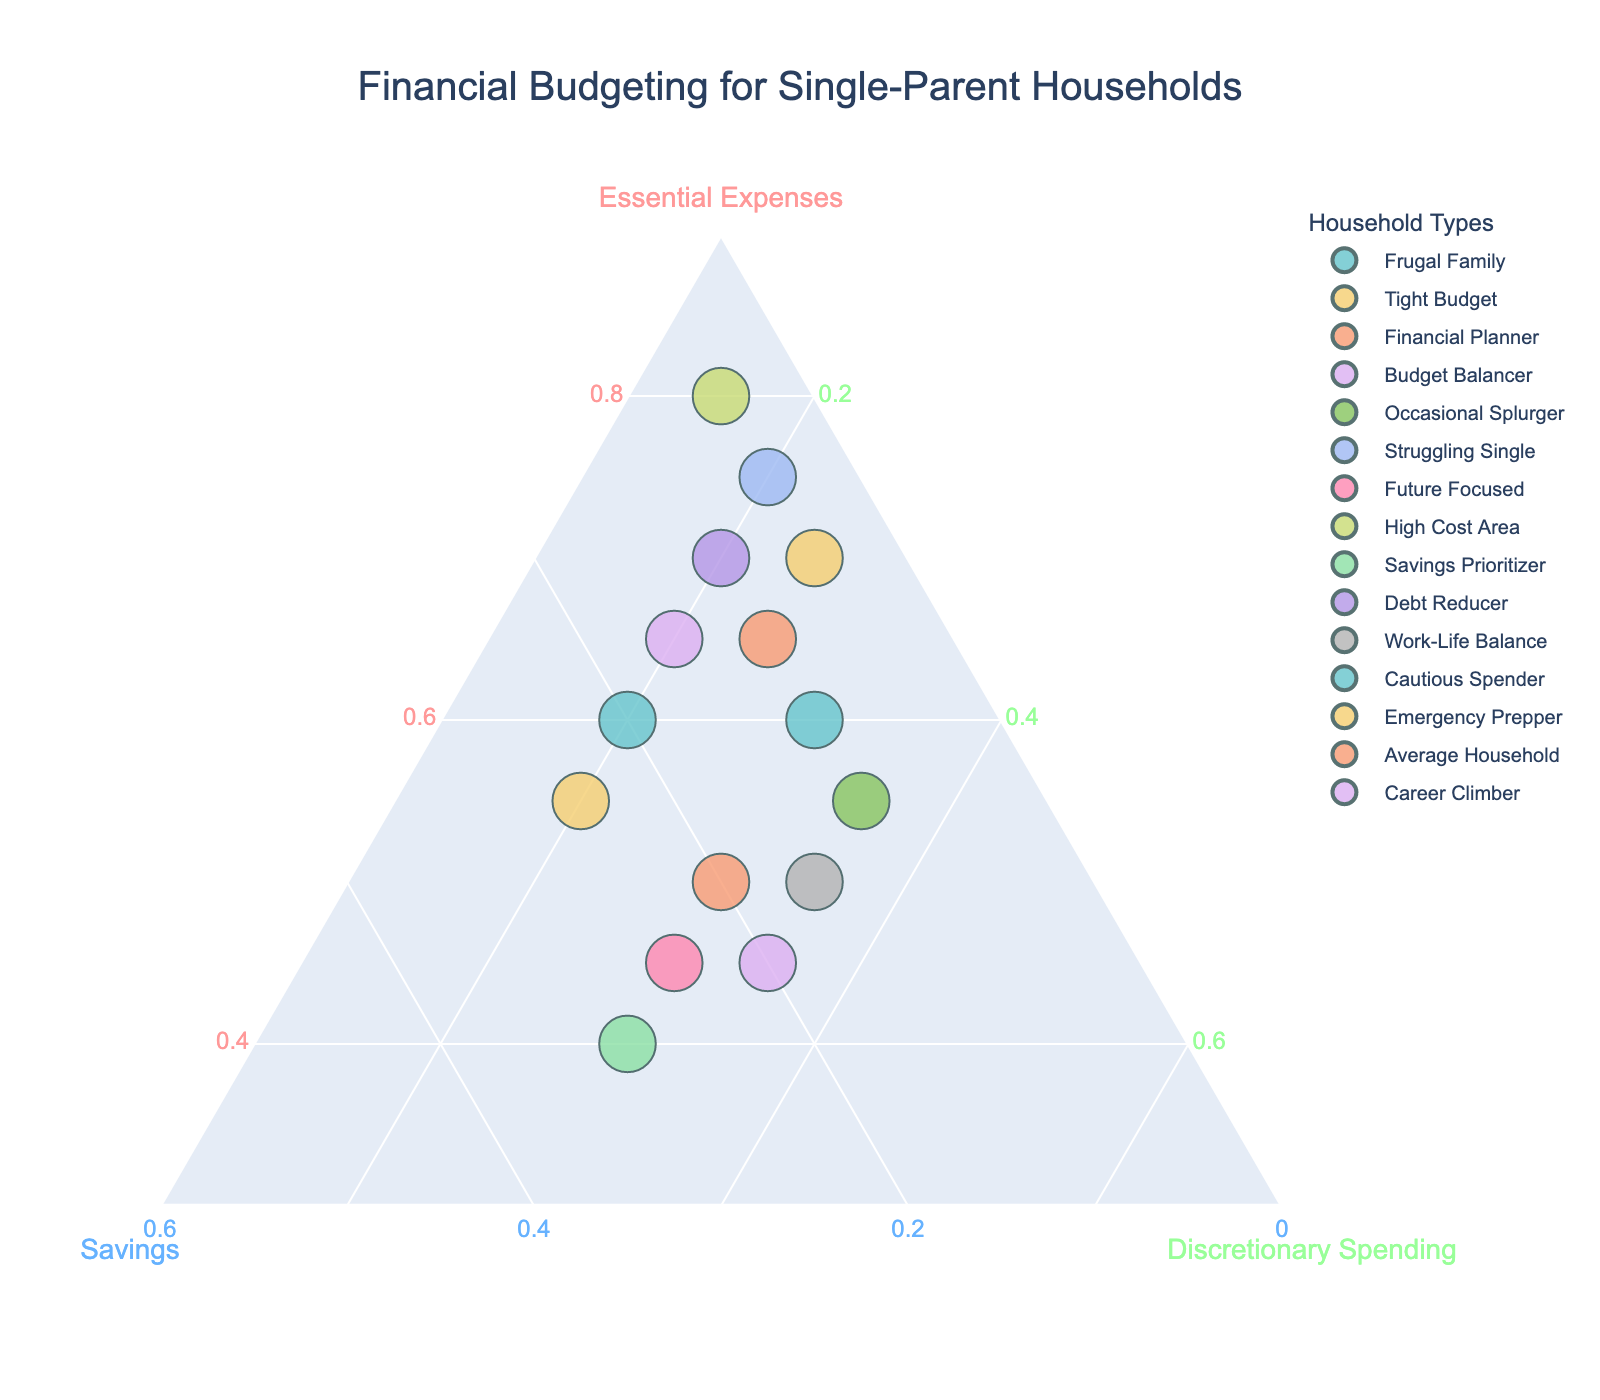What is the title of the plot? The title of the plot is usually located at the top and summarizes the main focus or subject of the chart. In this case, it reads "Financial Budgeting for Single-Parent Households".
Answer: Financial Budgeting for Single-Parent Households Which axis represents "Savings"? The axis labels help identify what each side of the ternary plot represents. The "Savings" label is typically positioned along one of the three axes. In this case, the "Savings" axis is labeled in blue.
Answer: Savings How many households have an essential expense of 70%? This can be identified by looking at the plot and observing which points lie along the 70% mark on the "Essential Expenses" axis. From the plot, "Tight Budget" and "Debt Reducer" have these values.
Answer: 2 Which household has the highest percentage in "Discretionary Spending"? On the plot, households with high discretionary spending will be positioned closer to the "Discretionary Spending" side of the ternary plot. In this case, "Occasional Splurger" and "Career Climber" each have 35%.
Answer: Occasional Splurger and Career Climber What is the sum of the percentages for "Financial Planner" household in all three categories? For "Financial Planner", sum the percentages of "Essential Expenses", "Savings", and "Discretionary Spending" which are 50%, 20%, and 30%, respectively. The sum is 50 + 20 + 30.
Answer: 100% Is "Struggling Single" spending more on "Discretionary Spending" than "Savings"? By comparing the values on the plot for "Struggling Single", you can see that "Discretionary Spending" is 20% and "Savings" is 5%.
Answer: Yes Which household focuses the most on "Savings"? By checking the plot for the data point closest to the "Savings" side, "Savings Prioritizer" with 30% stands out.
Answer: Savings Prioritizer Are there any households with equal percentages in any two categories? Examine the points on the plot to see if any household sits equally between any two axes. For example, "Cautious Spender" has an equal percentage of 20% in "Savings" and "Discretionary Spending".
Answer: Cautious Spender 